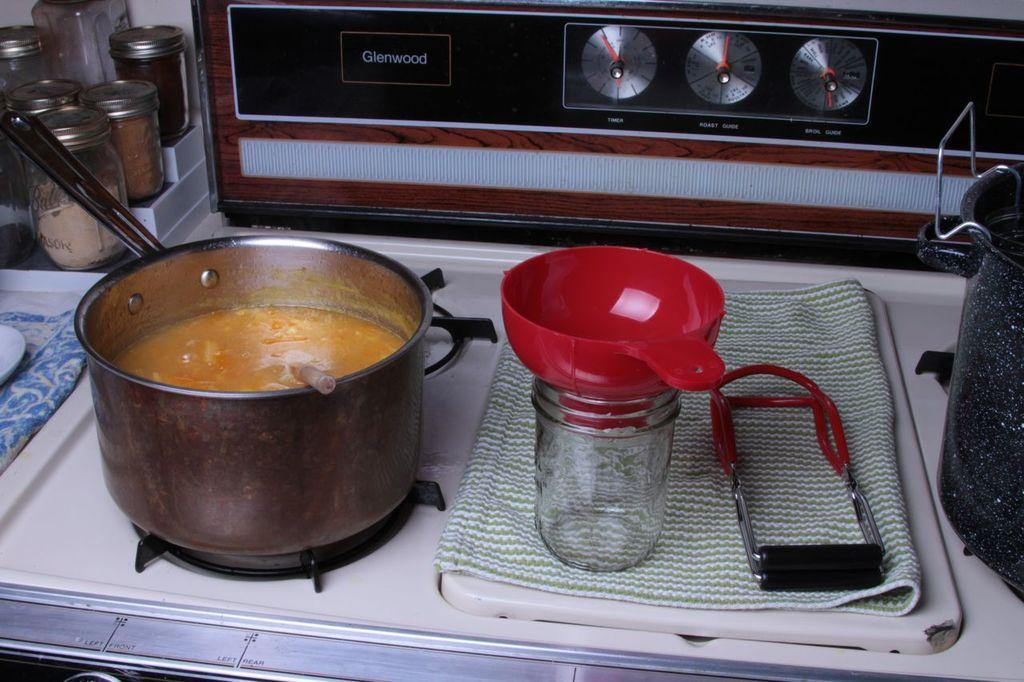What is on the stove in the image? There is a container on a stove. What is inside the container on the stove? The container has food in it. What is placed on the cloth in the image? There is a jar and a strainer on the cloth. Where are the jars with lids located in the image? There are jars with lids on the corner of a table. What book is the person reading in the image? There is no person reading a book in the image. Is the quilt made of cotton or wool in the image? There is no quilt present in the image. 